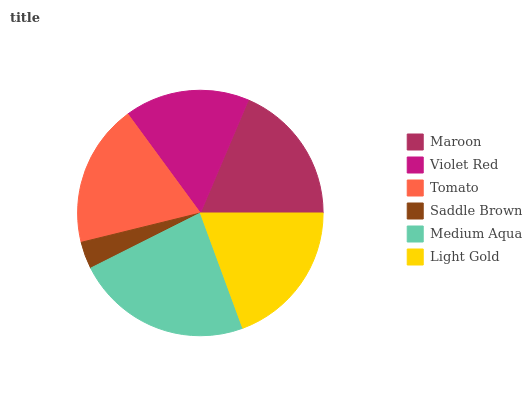Is Saddle Brown the minimum?
Answer yes or no. Yes. Is Medium Aqua the maximum?
Answer yes or no. Yes. Is Violet Red the minimum?
Answer yes or no. No. Is Violet Red the maximum?
Answer yes or no. No. Is Maroon greater than Violet Red?
Answer yes or no. Yes. Is Violet Red less than Maroon?
Answer yes or no. Yes. Is Violet Red greater than Maroon?
Answer yes or no. No. Is Maroon less than Violet Red?
Answer yes or no. No. Is Tomato the high median?
Answer yes or no. Yes. Is Maroon the low median?
Answer yes or no. Yes. Is Saddle Brown the high median?
Answer yes or no. No. Is Tomato the low median?
Answer yes or no. No. 